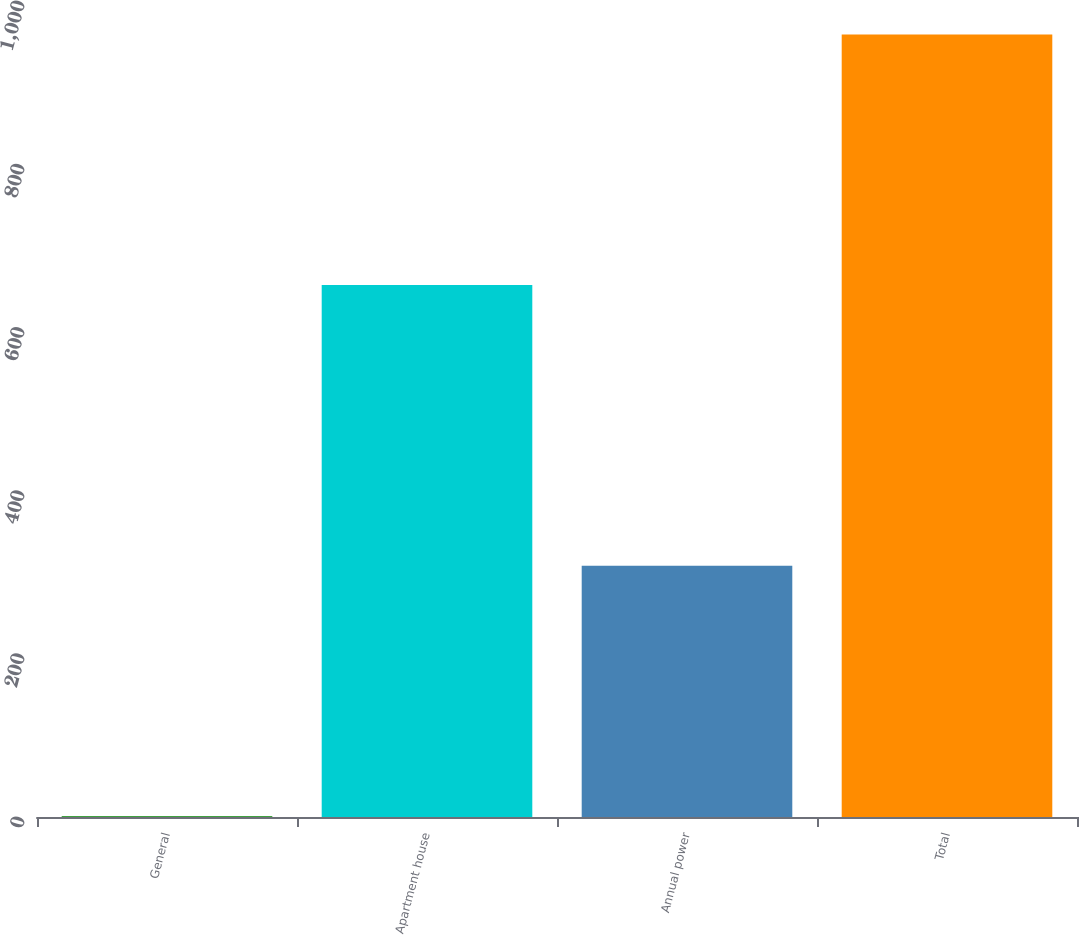Convert chart. <chart><loc_0><loc_0><loc_500><loc_500><bar_chart><fcel>General<fcel>Apartment house<fcel>Annual power<fcel>Total<nl><fcel>1<fcel>652<fcel>308<fcel>959<nl></chart> 